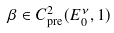<formula> <loc_0><loc_0><loc_500><loc_500>\beta \in C _ { \text {pre} } ^ { 2 } ( E _ { 0 } ^ { \nu } , 1 )</formula> 